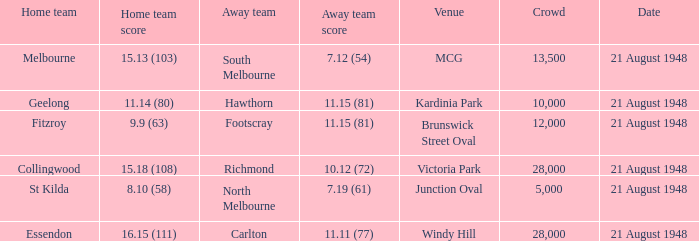If the Crowd is larger than 10,000 and the Away team score is 11.15 (81), what is the venue being played at? Brunswick Street Oval. 